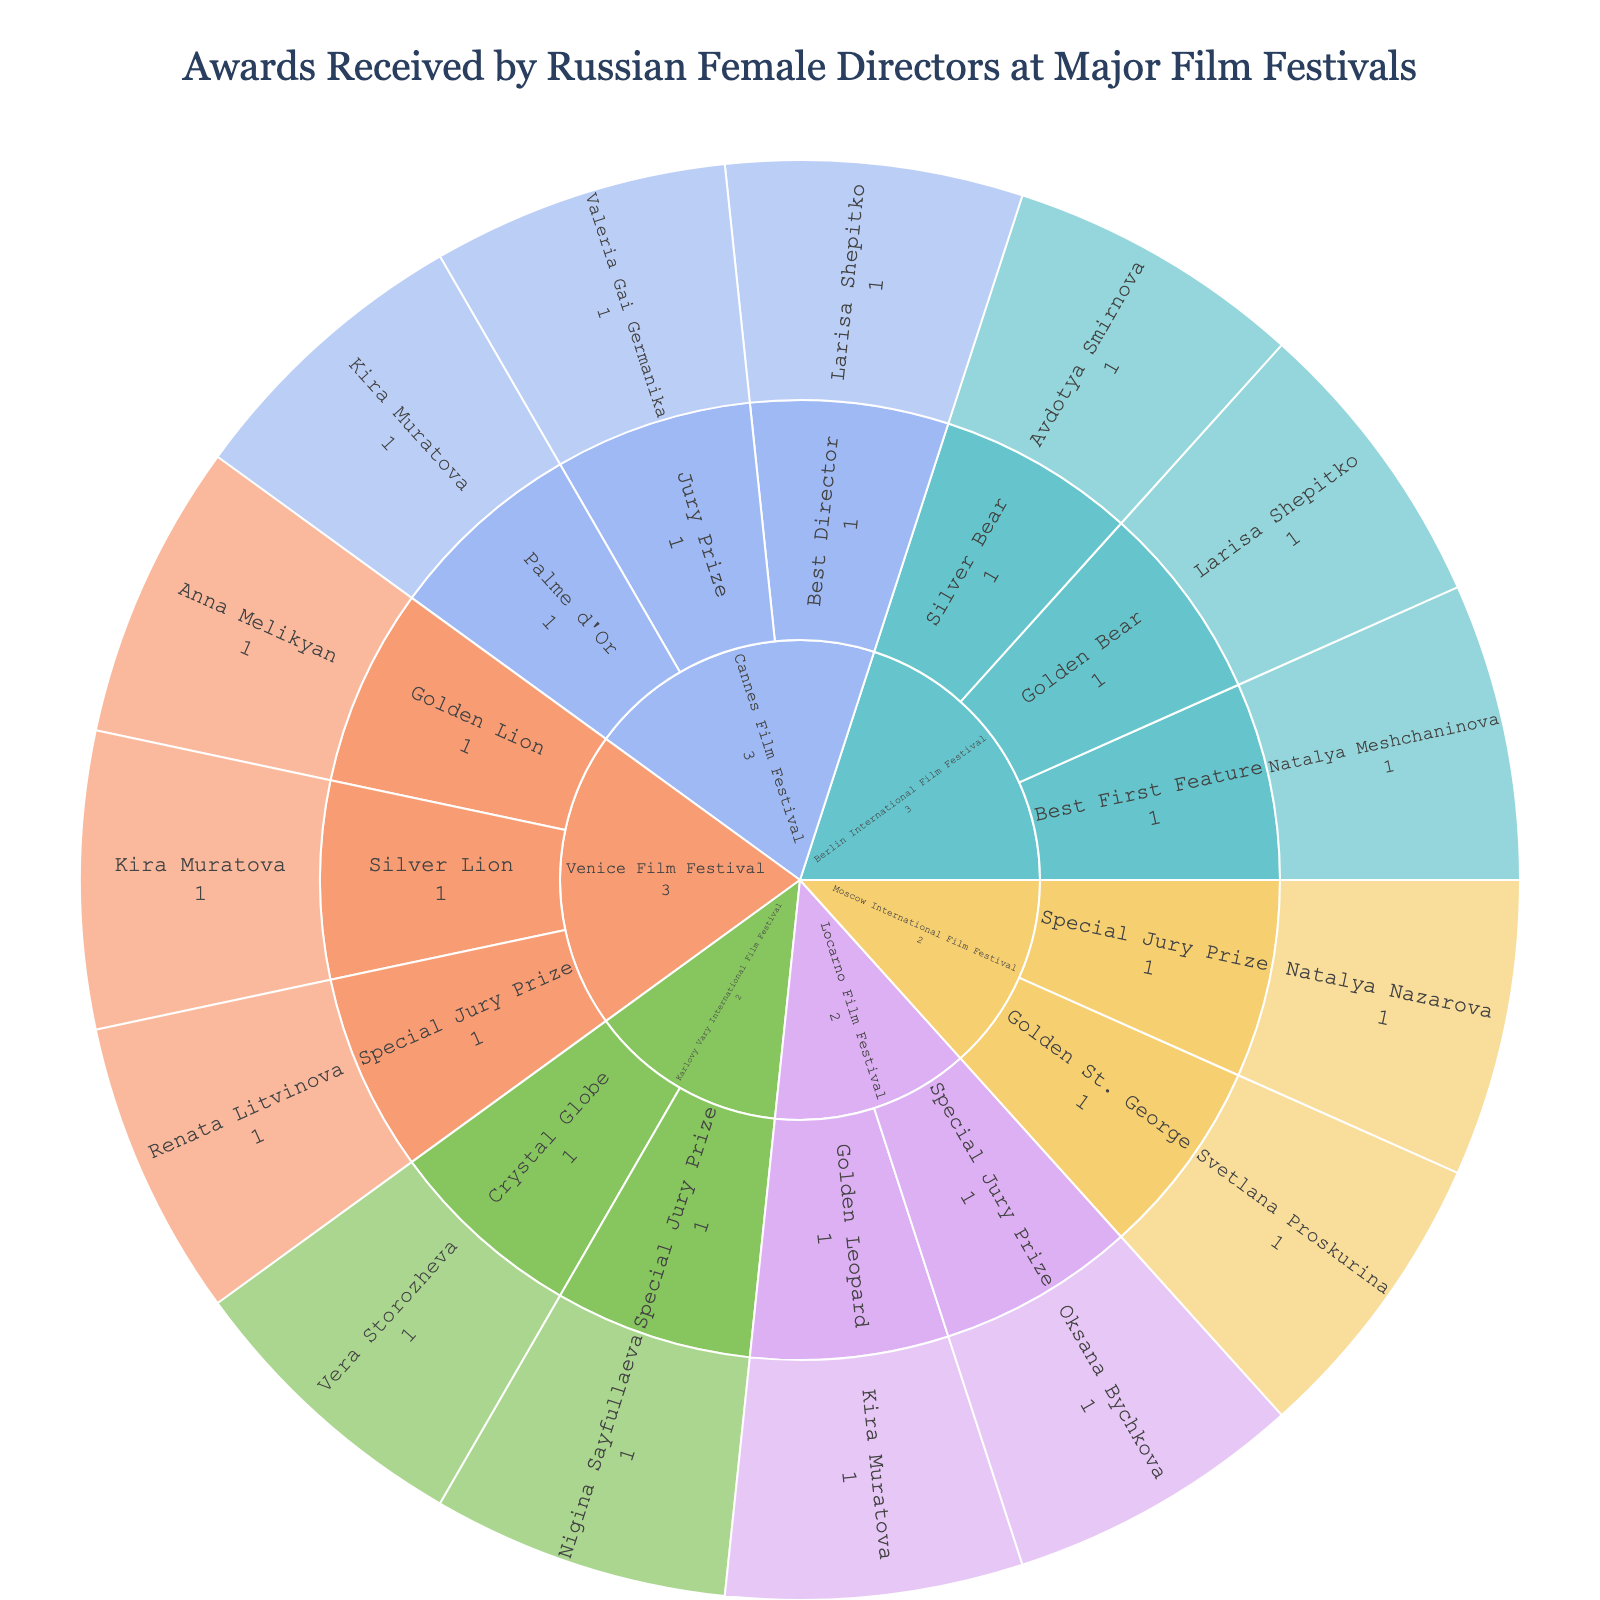How many festivals are represented in the plot? The plot categorizes the awards by festival, and each unique festival represents a segment in the layout. By counting these segments, we identify the number of festivals.
Answer: 6 Which director has received the most awards? To determine this, look for the director with the largest number of sub-segments or values across all categories and festivals. From the visualization, Kira Muratova appears multiple times with a total of four awards.
Answer: Kira Muratova How many awards were given for the "Special Jury Prize" category across all festivals? Count the number of awards under the “Special Jury Prize” category across all listed festivals. There are awards in the Cannes Film Festival, Venice Film Festival, Locarno Film Festival, Karlovy Vary International Film Festival, and Moscow International Film Festival.
Answer: 5 What is the total number of awards received by Russian female directors at the Cannes Film Festival? Sum the number of awards from each listed category (Palme d'Or, Best Director, Jury Prize) under the Cannes Film Festival. There are three categories with one award each.
Answer: 3 Which festival features the most diverse set of award categories? By examining each festival's segmentation, observe which festival has the most unique categories under it. Venice Film Festival has awards for the Golden Lion, Silver Lion, and Special Jury Prize.
Answer: Venice Film Festival How many directors have won an award at more than one festival? Identify directors with segments under more than one festival category. Kira Muratova has segments in Cannes, Venice, and Locarno film festivals.
Answer: 1 In which festival did Avdotya Smirnova win an award? Locate the segment for Avdotya Smirnova within the plot, which is under the Berlin International Film Festival.
Answer: Berlin International Film Festival Compare the number of awards received by directors at the Berlin International Film Festival with the Venice Film Festival. Which one is higher? Count the awards for each festival. Berlin International Film Festival lists three awards (Golden Bear, Silver Bear, Best First Feature), whereas Venice Film Festival lists four awards (Golden Lion, Silver Lion, Special Jury Prize).
Answer: Venice Film Festival How many different directors are represented in the plot? Count the unique names under the director category across all segments of the plot. There are thirteen different directors.
Answer: 13 